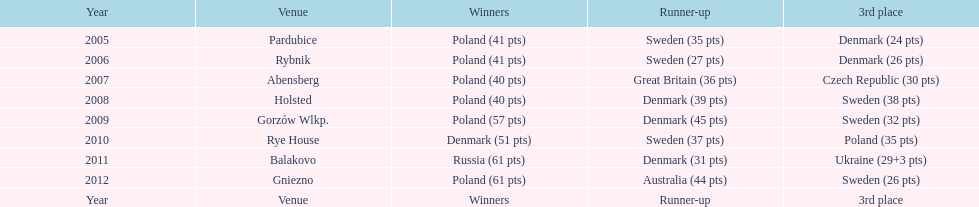Post 2008, what is the cumulative points scored by champions? 230. 